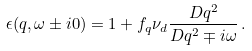Convert formula to latex. <formula><loc_0><loc_0><loc_500><loc_500>\epsilon ( { q } , \omega \pm i 0 ) = 1 + f _ { q } \nu _ { d } \frac { D { q } ^ { 2 } } { D { q } ^ { 2 } \mp i \omega } \, .</formula> 